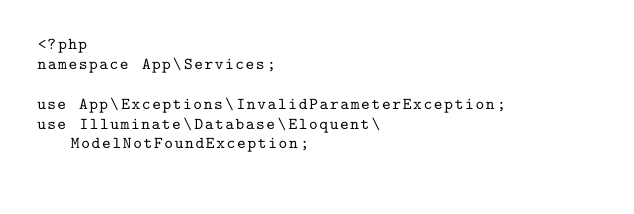Convert code to text. <code><loc_0><loc_0><loc_500><loc_500><_PHP_><?php
namespace App\Services;

use App\Exceptions\InvalidParameterException;
use Illuminate\Database\Eloquent\ModelNotFoundException;</code> 